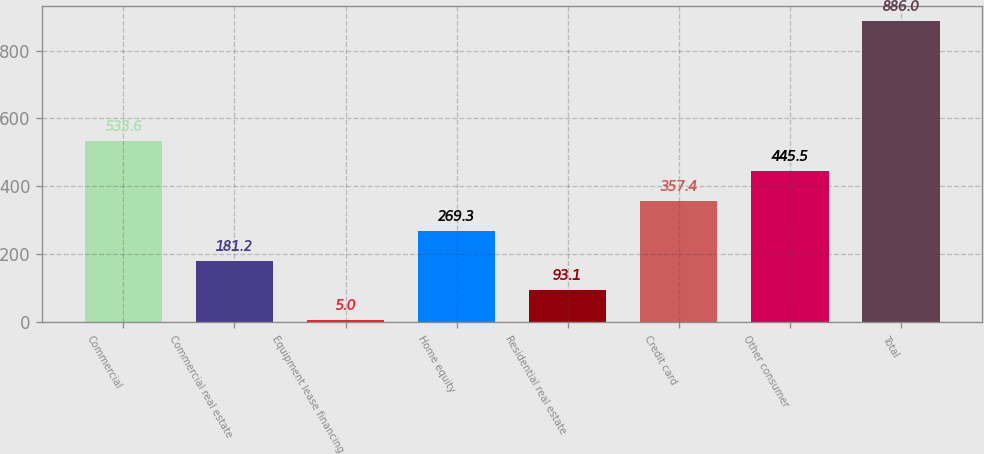Convert chart. <chart><loc_0><loc_0><loc_500><loc_500><bar_chart><fcel>Commercial<fcel>Commercial real estate<fcel>Equipment lease financing<fcel>Home equity<fcel>Residential real estate<fcel>Credit card<fcel>Other consumer<fcel>Total<nl><fcel>533.6<fcel>181.2<fcel>5<fcel>269.3<fcel>93.1<fcel>357.4<fcel>445.5<fcel>886<nl></chart> 